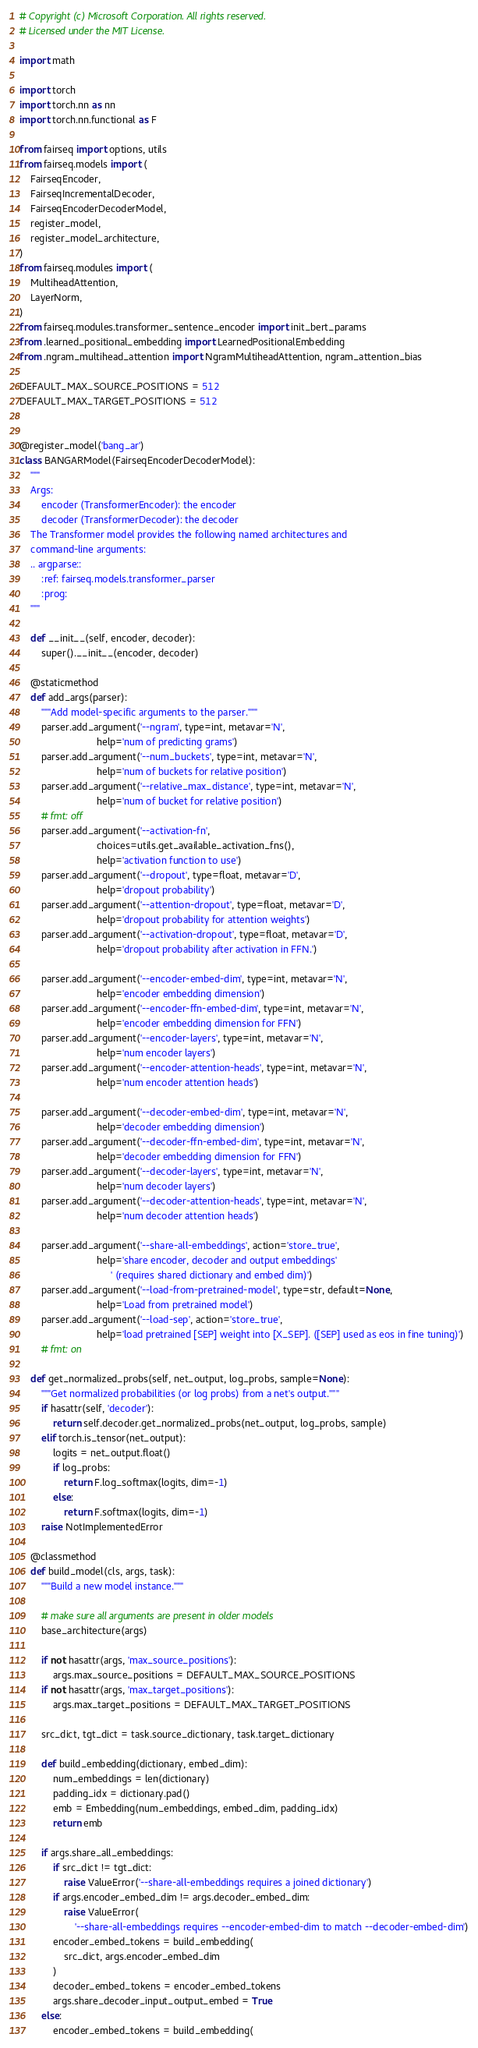<code> <loc_0><loc_0><loc_500><loc_500><_Python_># Copyright (c) Microsoft Corporation. All rights reserved.
# Licensed under the MIT License.

import math

import torch
import torch.nn as nn
import torch.nn.functional as F

from fairseq import options, utils
from fairseq.models import (
    FairseqEncoder,
    FairseqIncrementalDecoder,
    FairseqEncoderDecoderModel,
    register_model,
    register_model_architecture,
)
from fairseq.modules import (
    MultiheadAttention,
    LayerNorm,
)
from fairseq.modules.transformer_sentence_encoder import init_bert_params
from .learned_positional_embedding import LearnedPositionalEmbedding
from .ngram_multihead_attention import NgramMultiheadAttention, ngram_attention_bias

DEFAULT_MAX_SOURCE_POSITIONS = 512
DEFAULT_MAX_TARGET_POSITIONS = 512


@register_model('bang_ar')
class BANGARModel(FairseqEncoderDecoderModel):
    """
    Args:
        encoder (TransformerEncoder): the encoder
        decoder (TransformerDecoder): the decoder
    The Transformer model provides the following named architectures and
    command-line arguments:
    .. argparse::
        :ref: fairseq.models.transformer_parser
        :prog:
    """

    def __init__(self, encoder, decoder):
        super().__init__(encoder, decoder)

    @staticmethod
    def add_args(parser):
        """Add model-specific arguments to the parser."""
        parser.add_argument('--ngram', type=int, metavar='N',
                            help='num of predicting grams')
        parser.add_argument('--num_buckets', type=int, metavar='N',
                            help='num of buckets for relative position')
        parser.add_argument('--relative_max_distance', type=int, metavar='N',
                            help='num of bucket for relative position')
        # fmt: off
        parser.add_argument('--activation-fn',
                            choices=utils.get_available_activation_fns(),
                            help='activation function to use')
        parser.add_argument('--dropout', type=float, metavar='D',
                            help='dropout probability')
        parser.add_argument('--attention-dropout', type=float, metavar='D',
                            help='dropout probability for attention weights')
        parser.add_argument('--activation-dropout', type=float, metavar='D',
                            help='dropout probability after activation in FFN.')

        parser.add_argument('--encoder-embed-dim', type=int, metavar='N',
                            help='encoder embedding dimension')
        parser.add_argument('--encoder-ffn-embed-dim', type=int, metavar='N',
                            help='encoder embedding dimension for FFN')
        parser.add_argument('--encoder-layers', type=int, metavar='N',
                            help='num encoder layers')
        parser.add_argument('--encoder-attention-heads', type=int, metavar='N',
                            help='num encoder attention heads')

        parser.add_argument('--decoder-embed-dim', type=int, metavar='N',
                            help='decoder embedding dimension')
        parser.add_argument('--decoder-ffn-embed-dim', type=int, metavar='N',
                            help='decoder embedding dimension for FFN')
        parser.add_argument('--decoder-layers', type=int, metavar='N',
                            help='num decoder layers')
        parser.add_argument('--decoder-attention-heads', type=int, metavar='N',
                            help='num decoder attention heads')

        parser.add_argument('--share-all-embeddings', action='store_true',
                            help='share encoder, decoder and output embeddings'
                                 ' (requires shared dictionary and embed dim)')
        parser.add_argument('--load-from-pretrained-model', type=str, default=None,
                            help='Load from pretrained model')
        parser.add_argument('--load-sep', action='store_true',
                            help='load pretrained [SEP] weight into [X_SEP]. ([SEP] used as eos in fine tuning)')
        # fmt: on

    def get_normalized_probs(self, net_output, log_probs, sample=None):
        """Get normalized probabilities (or log probs) from a net's output."""
        if hasattr(self, 'decoder'):
            return self.decoder.get_normalized_probs(net_output, log_probs, sample)
        elif torch.is_tensor(net_output):
            logits = net_output.float()
            if log_probs:
                return F.log_softmax(logits, dim=-1)
            else:
                return F.softmax(logits, dim=-1)
        raise NotImplementedError

    @classmethod
    def build_model(cls, args, task):
        """Build a new model instance."""

        # make sure all arguments are present in older models
        base_architecture(args)

        if not hasattr(args, 'max_source_positions'):
            args.max_source_positions = DEFAULT_MAX_SOURCE_POSITIONS
        if not hasattr(args, 'max_target_positions'):
            args.max_target_positions = DEFAULT_MAX_TARGET_POSITIONS

        src_dict, tgt_dict = task.source_dictionary, task.target_dictionary

        def build_embedding(dictionary, embed_dim):
            num_embeddings = len(dictionary)
            padding_idx = dictionary.pad()
            emb = Embedding(num_embeddings, embed_dim, padding_idx)
            return emb

        if args.share_all_embeddings:
            if src_dict != tgt_dict:
                raise ValueError('--share-all-embeddings requires a joined dictionary')
            if args.encoder_embed_dim != args.decoder_embed_dim:
                raise ValueError(
                    '--share-all-embeddings requires --encoder-embed-dim to match --decoder-embed-dim')
            encoder_embed_tokens = build_embedding(
                src_dict, args.encoder_embed_dim
            )
            decoder_embed_tokens = encoder_embed_tokens
            args.share_decoder_input_output_embed = True
        else:
            encoder_embed_tokens = build_embedding(</code> 